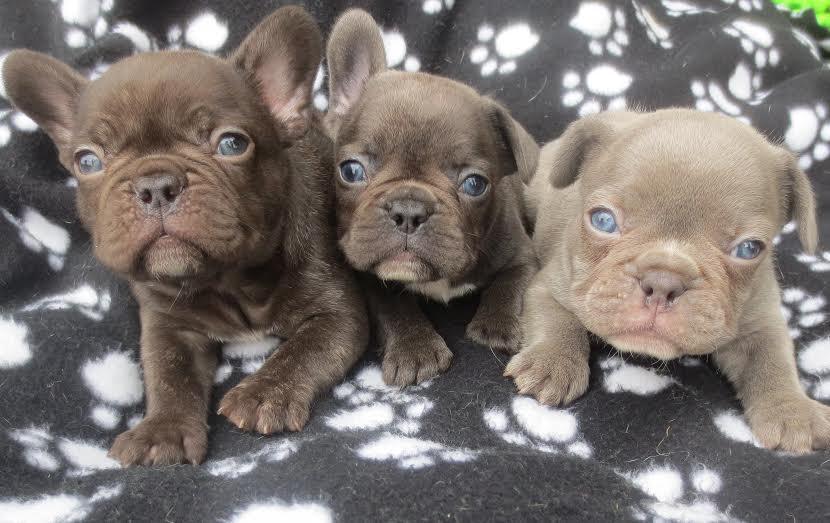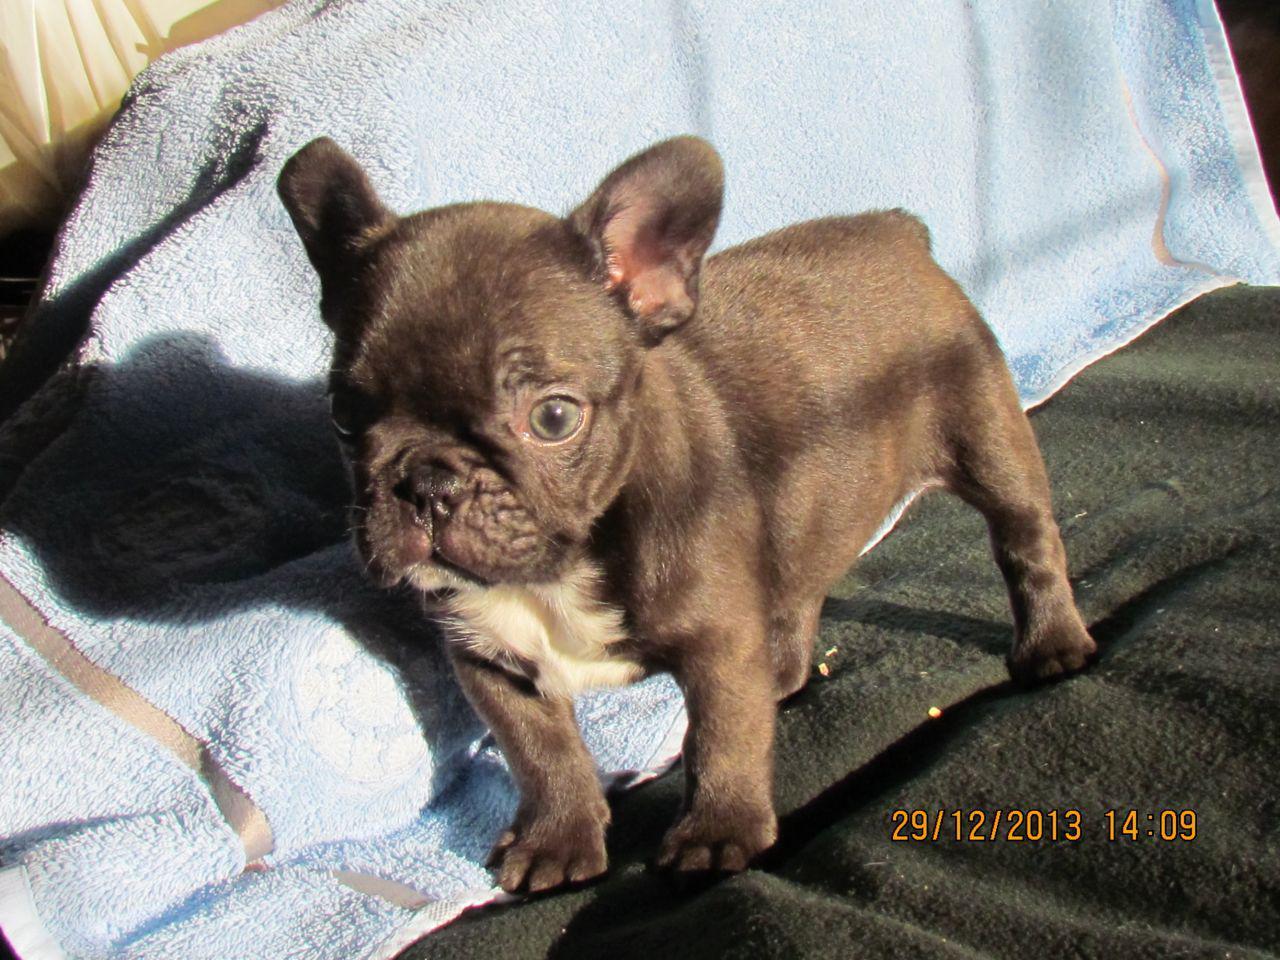The first image is the image on the left, the second image is the image on the right. Examine the images to the left and right. Is the description "The left image contains exactly two dogs." accurate? Answer yes or no. No. The first image is the image on the left, the second image is the image on the right. Given the left and right images, does the statement "Each image contains exactly two bulldogs, and the two dogs on the left are the same color, while the right image features a dark dog next to a lighter one." hold true? Answer yes or no. No. 